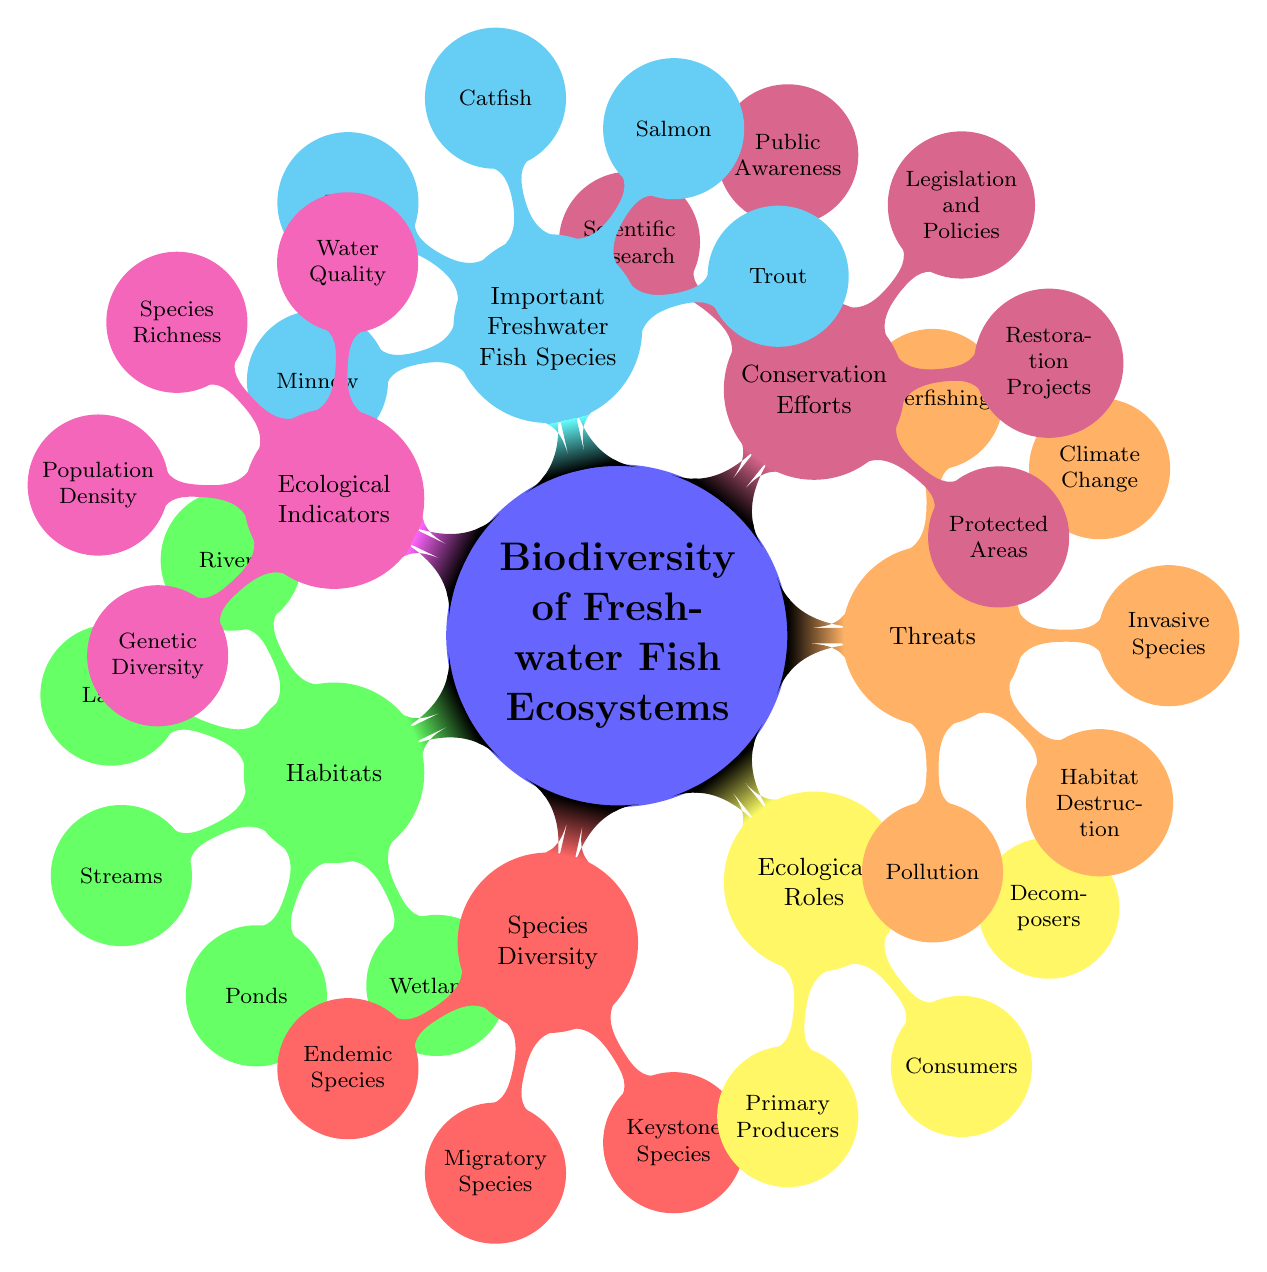What are the main habitats listed in the diagram? The main habitats are branches under the "Habitats" node. There are five elements listed: Rivers, Lakes, Streams, Ponds, and Wetlands.
Answer: Rivers, Lakes, Streams, Ponds, Wetlands How many species types are mentioned in the "Species Diversity" category? The "Species Diversity" node has three elements listed: Endemic Species, Migratory Species, and Keystone Species. Therefore, there are three species types mentioned.
Answer: 3 What ecological roles do freshwater fish contribute as listed in the diagram? The "Ecological Roles" node contains three elements: Primary Producers, Consumers, and Decomposers.
Answer: Primary Producers, Consumers, Decomposers What threats to freshwater fish ecosystems are identified in the diagram? The "Threats" node outlines five elements: Pollution, Habitat Destruction, Invasive Species, Climate Change, and Overfishing.
Answer: Pollution, Habitat Destruction, Invasive Species, Climate Change, Overfishing Which category includes "Scientific Research"? "Scientific Research" is listed under the "Conservation Efforts" node. This node encompasses multiple efforts aimed at preserving biodiversity in freshwater fish ecosystems.
Answer: Conservation Efforts How many important freshwater fish species are listed in the diagram? In the "Important Freshwater Fish Species" node, there are five elements: Trout, Salmon, Catfish, Bass, and Minnow. Therefore, five species are identified.
Answer: 5 Which indicator relates to the health of the water in freshwater ecosystems? "Water Quality" is the specific indicator mentioned under the "Ecological Indicators" node that relates to the health of the water in freshwater ecosystems.
Answer: Water Quality What is the relationship between "Invasive Species" and "Habitat Destruction"? Both "Invasive Species" and "Habitat Destruction" are listed under the same node, which is "Threats." This indicates that both are threats to freshwater fish ecosystems.
Answer: Threats Which ecological role can be associated with primary producers? The "Ecological Roles" node identifies "Primary Producers," which refers to organisms that generate energy through photosynthesis or chemosynthesis.
Answer: Primary Producers 